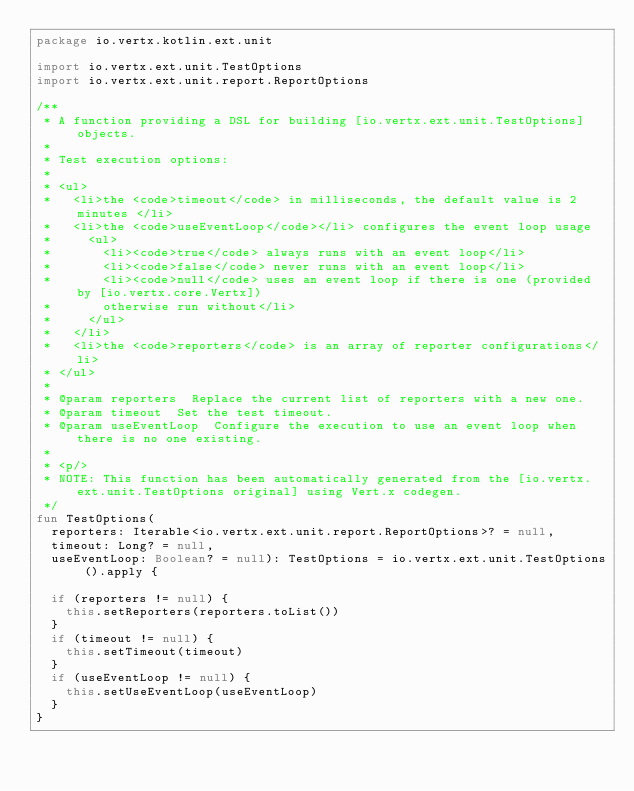<code> <loc_0><loc_0><loc_500><loc_500><_Kotlin_>package io.vertx.kotlin.ext.unit

import io.vertx.ext.unit.TestOptions
import io.vertx.ext.unit.report.ReportOptions

/**
 * A function providing a DSL for building [io.vertx.ext.unit.TestOptions] objects.
 *
 * Test execution options:
 *
 * <ul>
 *   <li>the <code>timeout</code> in milliseconds, the default value is 2 minutes </li>
 *   <li>the <code>useEventLoop</code></li> configures the event loop usage
 *     <ul>
 *       <li><code>true</code> always runs with an event loop</li>
 *       <li><code>false</code> never runs with an event loop</li>
 *       <li><code>null</code> uses an event loop if there is one (provided by [io.vertx.core.Vertx])
 *       otherwise run without</li>
 *     </ul>
 *   </li>
 *   <li>the <code>reporters</code> is an array of reporter configurations</li>
 * </ul>
 *
 * @param reporters  Replace the current list of reporters with a new one.
 * @param timeout  Set the test timeout.
 * @param useEventLoop  Configure the execution to use an event loop when there is no one existing.
 *
 * <p/>
 * NOTE: This function has been automatically generated from the [io.vertx.ext.unit.TestOptions original] using Vert.x codegen.
 */
fun TestOptions(
  reporters: Iterable<io.vertx.ext.unit.report.ReportOptions>? = null,
  timeout: Long? = null,
  useEventLoop: Boolean? = null): TestOptions = io.vertx.ext.unit.TestOptions().apply {

  if (reporters != null) {
    this.setReporters(reporters.toList())
  }
  if (timeout != null) {
    this.setTimeout(timeout)
  }
  if (useEventLoop != null) {
    this.setUseEventLoop(useEventLoop)
  }
}

</code> 